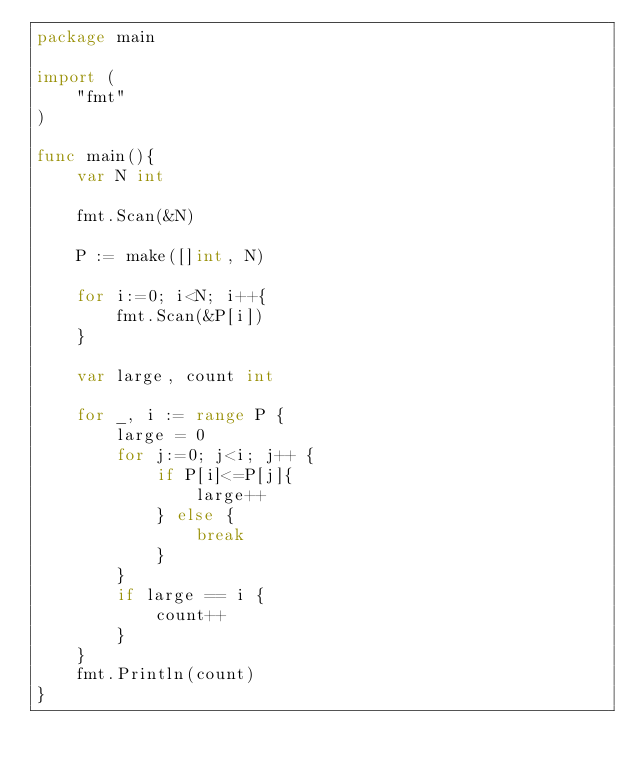Convert code to text. <code><loc_0><loc_0><loc_500><loc_500><_Go_>package main

import (
    "fmt"
)

func main(){
    var N int

    fmt.Scan(&N)

    P := make([]int, N)

    for i:=0; i<N; i++{
        fmt.Scan(&P[i])
    }

    var large, count int

    for _, i := range P {
        large = 0
        for j:=0; j<i; j++ {
            if P[i]<=P[j]{
                large++
            } else {
                break
            }
        }
        if large == i {
            count++
        }
    }
    fmt.Println(count)
}
</code> 